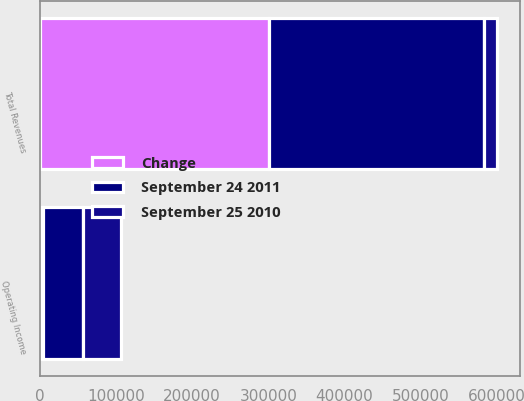Convert chart to OTSL. <chart><loc_0><loc_0><loc_500><loc_500><stacked_bar_chart><ecel><fcel>Total Revenues<fcel>Operating Income<nl><fcel>Change<fcel>300538<fcel>3623<nl><fcel>September 24 2011<fcel>283142<fcel>53071<nl><fcel>September 25 2010<fcel>17396<fcel>49448<nl></chart> 